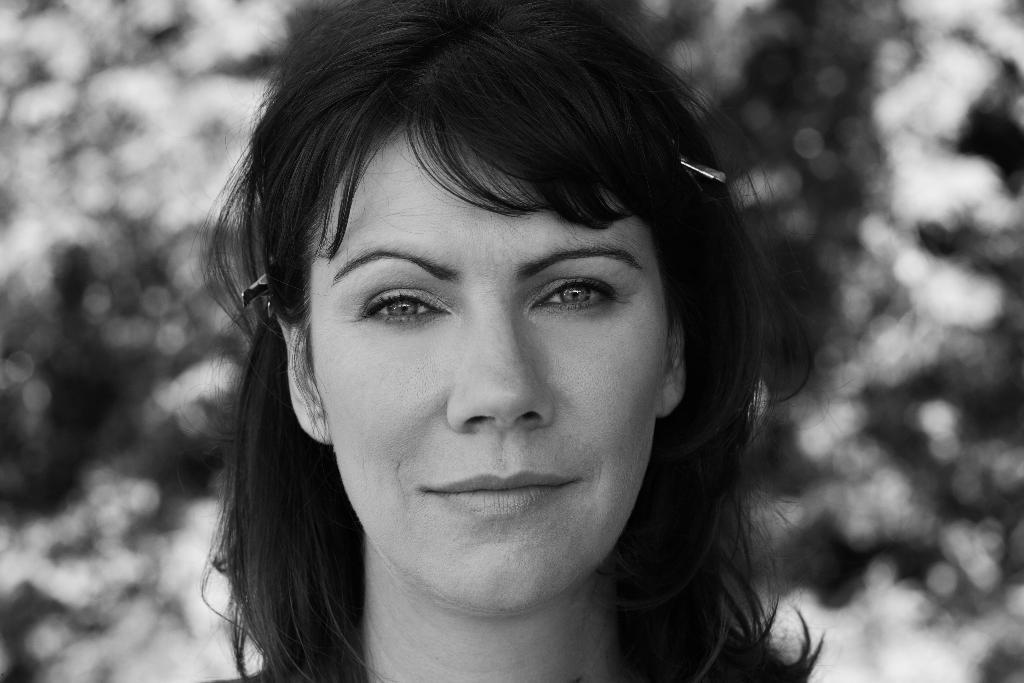Can you describe this image briefly? In the image we can see there is a face of a woman and the image is in black and white colour. 